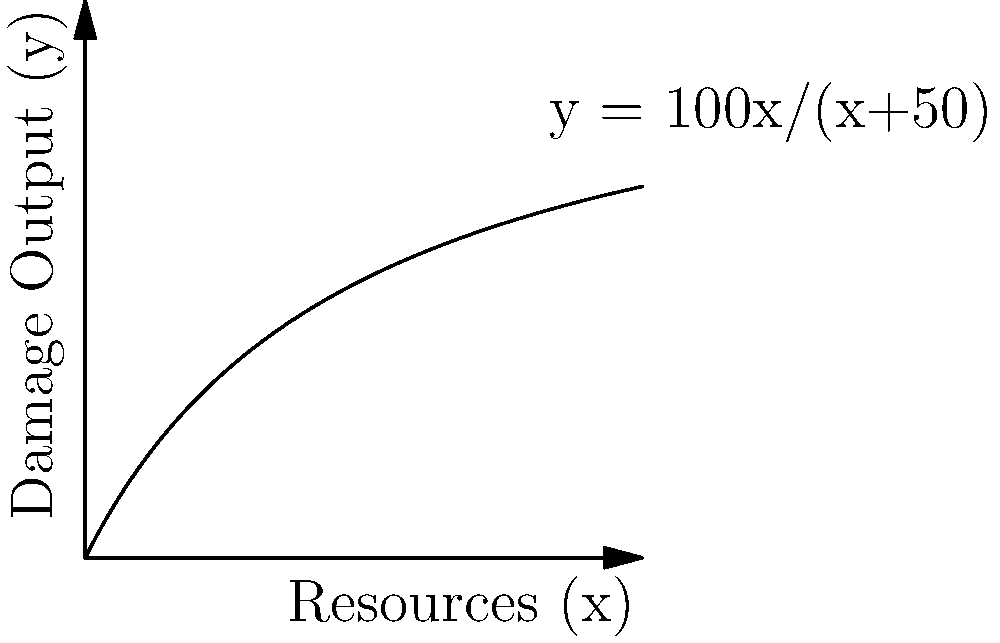In a strategy game, your damage output (y) is related to the resources invested (x) according to the function $y = \frac{100x}{x+50}$. You have 75 resource units available. What is the maximum damage output you can achieve, and how many resource units should you invest to reach this maximum? To solve this optimization problem, we need to follow these steps:

1) First, we need to understand that the function $y = \frac{100x}{x+50}$ approaches 100 as x approaches infinity. This means the maximum damage output is always less than 100.

2) Given that we have 75 resource units, we need to find the value of y when x = 75:

   $y = \frac{100(75)}{75+50} = \frac{7500}{125} = 60$

3) This tells us that using all 75 resource units will give us a damage output of 60.

4) To check if this is the maximum, we can calculate the derivative of the function:

   $y' = \frac{100(x+50) - 100x}{(x+50)^2} = \frac{5000}{(x+50)^2}$

5) The derivative is always positive, which means the function is always increasing. Therefore, using all available resources will always give the maximum damage output.

6) Thus, the maximum damage output is achieved by investing all 75 resource units, resulting in a damage output of 60.
Answer: Maximum damage output: 60; Invest all 75 resource units. 